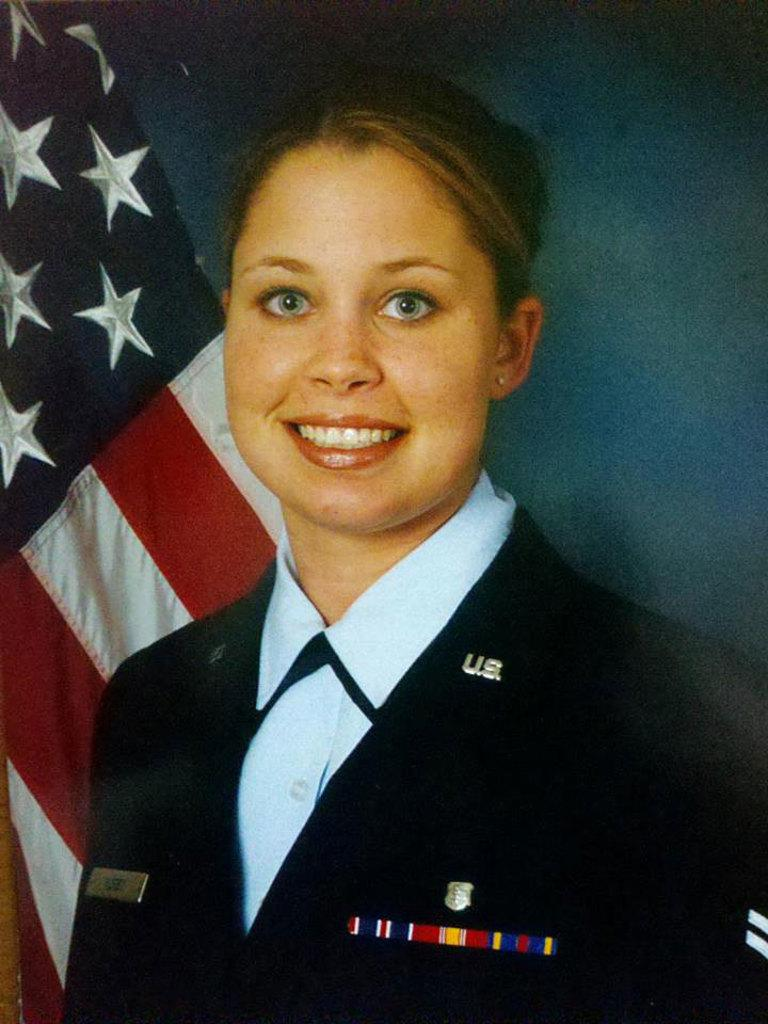Who is the main subject in the foreground of the image? There is a woman in the foreground of the image. What is the woman doing in the image? The woman is smiling. What symbol can be seen in the image? There is an American flag visible in the image. What does the woman desire to achieve in the image? There is no information provided about the woman's desires or goals in the image. What does the woman believe about the American flag in the image? There is: There is no information provided about the woman's beliefs or opinions regarding the American flag in the image. 